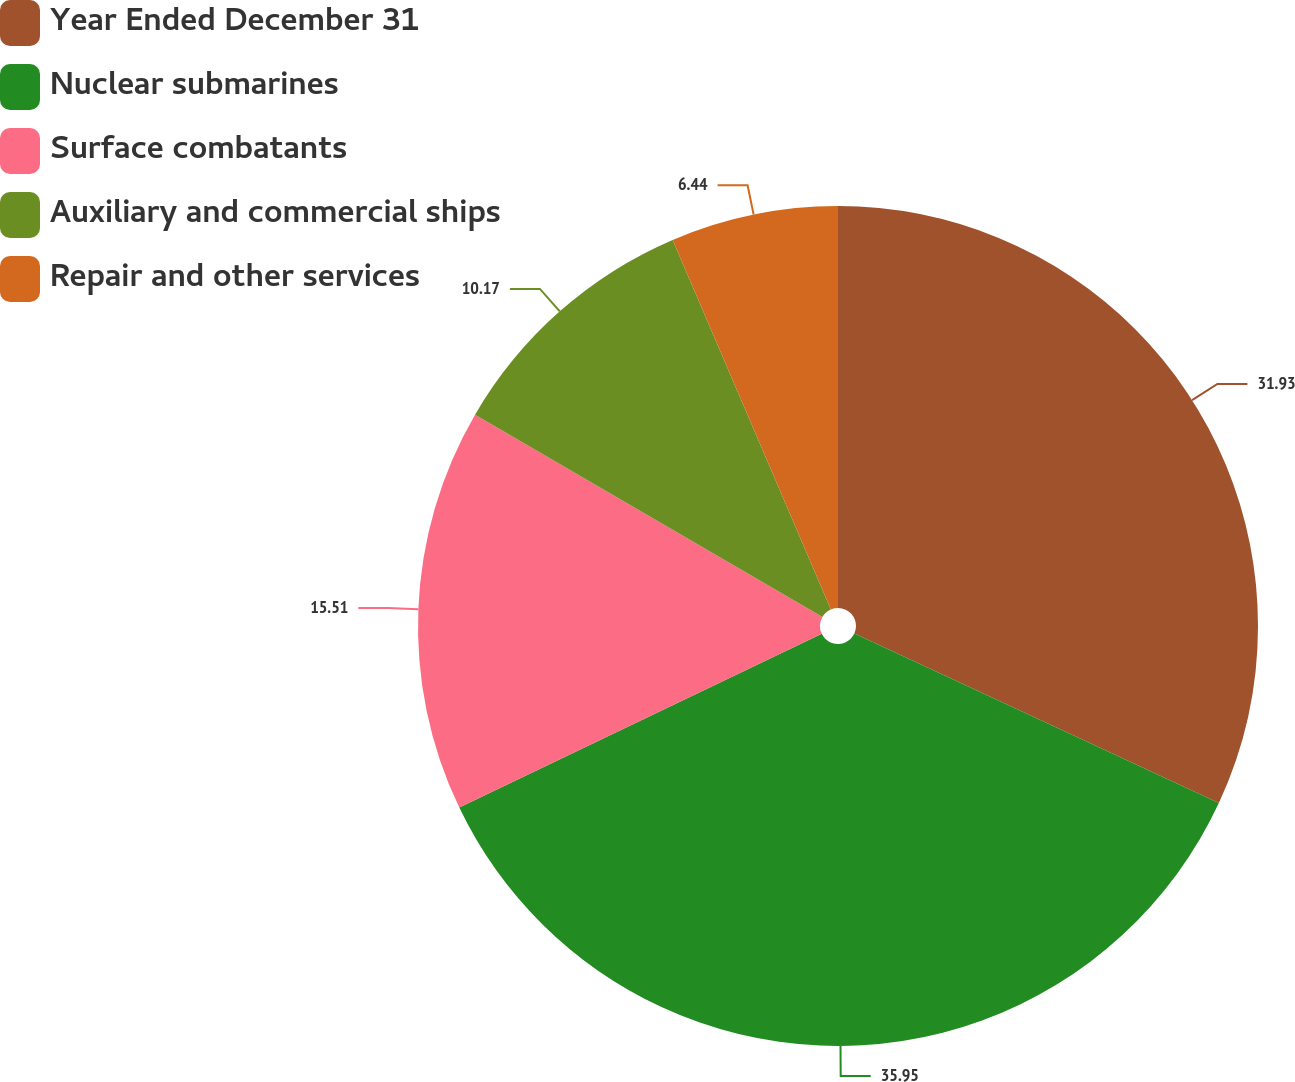Convert chart. <chart><loc_0><loc_0><loc_500><loc_500><pie_chart><fcel>Year Ended December 31<fcel>Nuclear submarines<fcel>Surface combatants<fcel>Auxiliary and commercial ships<fcel>Repair and other services<nl><fcel>31.93%<fcel>35.96%<fcel>15.51%<fcel>10.17%<fcel>6.44%<nl></chart> 